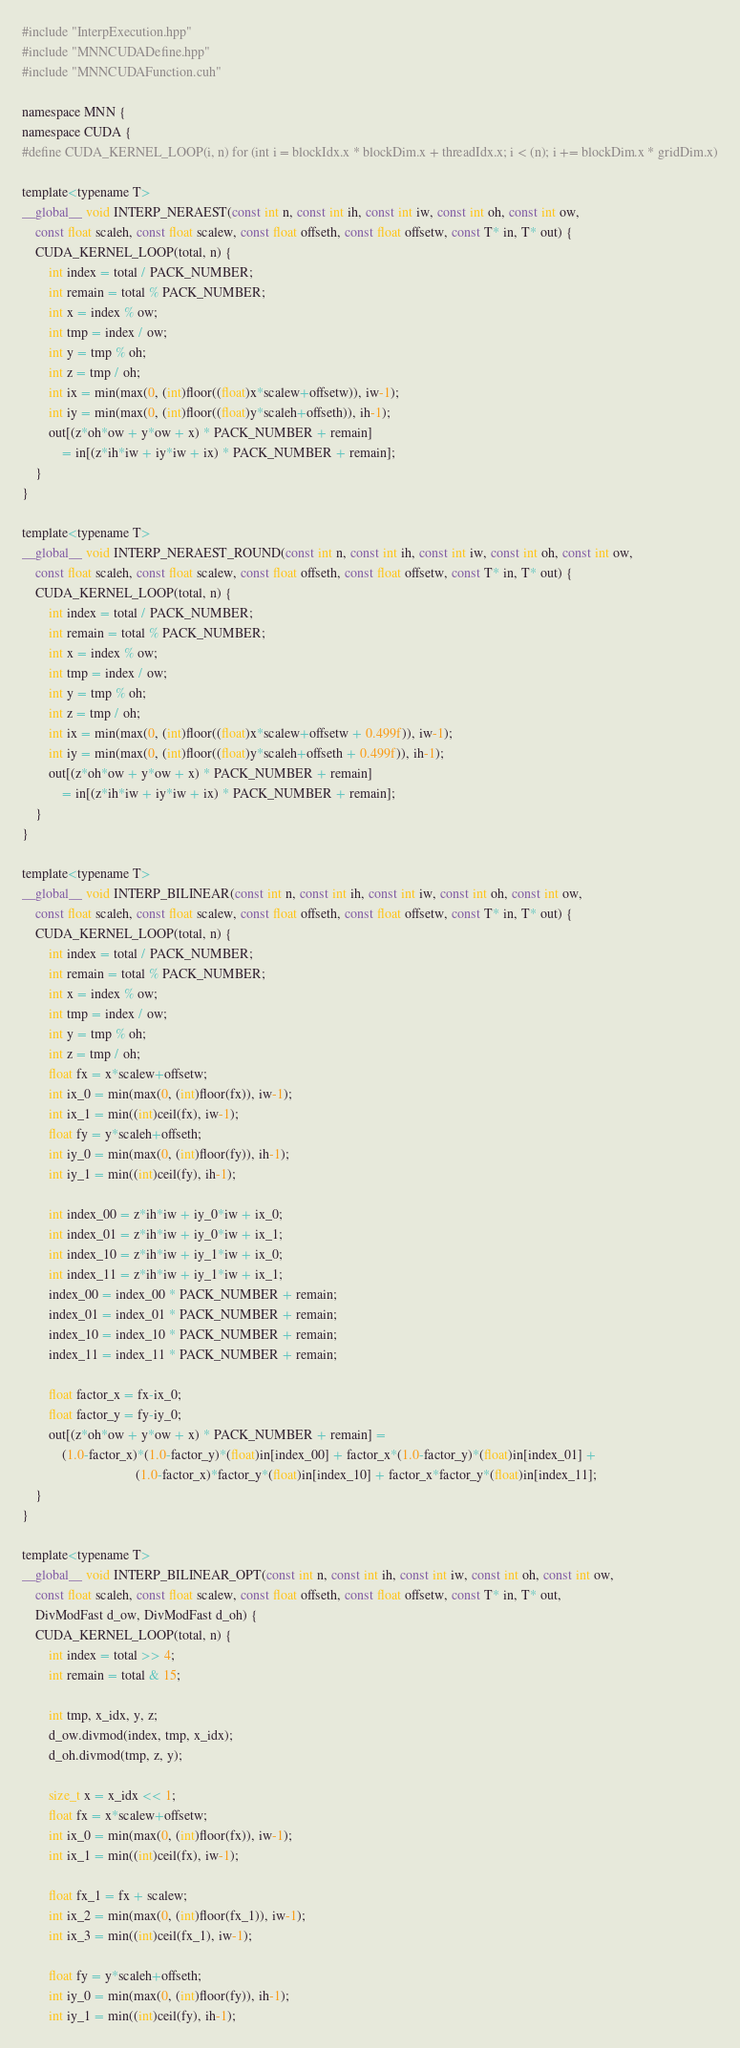<code> <loc_0><loc_0><loc_500><loc_500><_Cuda_>#include "InterpExecution.hpp"
#include "MNNCUDADefine.hpp"
#include "MNNCUDAFunction.cuh"

namespace MNN {
namespace CUDA {
#define CUDA_KERNEL_LOOP(i, n) for (int i = blockIdx.x * blockDim.x + threadIdx.x; i < (n); i += blockDim.x * gridDim.x)

template<typename T>
__global__ void INTERP_NERAEST(const int n, const int ih, const int iw, const int oh, const int ow, 
    const float scaleh, const float scalew, const float offseth, const float offsetw, const T* in, T* out) {
    CUDA_KERNEL_LOOP(total, n) {
        int index = total / PACK_NUMBER;
        int remain = total % PACK_NUMBER;
        int x = index % ow;
        int tmp = index / ow;
        int y = tmp % oh;
        int z = tmp / oh;
        int ix = min(max(0, (int)floor((float)x*scalew+offsetw)), iw-1);
        int iy = min(max(0, (int)floor((float)y*scaleh+offseth)), ih-1);
        out[(z*oh*ow + y*ow + x) * PACK_NUMBER + remain]
            = in[(z*ih*iw + iy*iw + ix) * PACK_NUMBER + remain];
    }
}

template<typename T>
__global__ void INTERP_NERAEST_ROUND(const int n, const int ih, const int iw, const int oh, const int ow, 
    const float scaleh, const float scalew, const float offseth, const float offsetw, const T* in, T* out) {
    CUDA_KERNEL_LOOP(total, n) {
        int index = total / PACK_NUMBER;
        int remain = total % PACK_NUMBER;
        int x = index % ow;
        int tmp = index / ow;
        int y = tmp % oh;
        int z = tmp / oh;
        int ix = min(max(0, (int)floor((float)x*scalew+offsetw + 0.499f)), iw-1);
        int iy = min(max(0, (int)floor((float)y*scaleh+offseth + 0.499f)), ih-1);
        out[(z*oh*ow + y*ow + x) * PACK_NUMBER + remain]
            = in[(z*ih*iw + iy*iw + ix) * PACK_NUMBER + remain];
    }
}

template<typename T>
__global__ void INTERP_BILINEAR(const int n, const int ih, const int iw, const int oh, const int ow, 
    const float scaleh, const float scalew, const float offseth, const float offsetw, const T* in, T* out) {
    CUDA_KERNEL_LOOP(total, n) {
        int index = total / PACK_NUMBER;
        int remain = total % PACK_NUMBER;
        int x = index % ow;
        int tmp = index / ow;
        int y = tmp % oh;
        int z = tmp / oh;
        float fx = x*scalew+offsetw;
        int ix_0 = min(max(0, (int)floor(fx)), iw-1);
        int ix_1 = min((int)ceil(fx), iw-1);
        float fy = y*scaleh+offseth;
        int iy_0 = min(max(0, (int)floor(fy)), ih-1);
        int iy_1 = min((int)ceil(fy), ih-1);

        int index_00 = z*ih*iw + iy_0*iw + ix_0;
        int index_01 = z*ih*iw + iy_0*iw + ix_1;
        int index_10 = z*ih*iw + iy_1*iw + ix_0;
        int index_11 = z*ih*iw + iy_1*iw + ix_1;
        index_00 = index_00 * PACK_NUMBER + remain;
        index_01 = index_01 * PACK_NUMBER + remain;
        index_10 = index_10 * PACK_NUMBER + remain;
        index_11 = index_11 * PACK_NUMBER + remain;

        float factor_x = fx-ix_0;
        float factor_y = fy-iy_0;
        out[(z*oh*ow + y*ow + x) * PACK_NUMBER + remain] =
            (1.0-factor_x)*(1.0-factor_y)*(float)in[index_00] + factor_x*(1.0-factor_y)*(float)in[index_01] +
                                  (1.0-factor_x)*factor_y*(float)in[index_10] + factor_x*factor_y*(float)in[index_11];
    }
}

template<typename T>
__global__ void INTERP_BILINEAR_OPT(const int n, const int ih, const int iw, const int oh, const int ow, 
    const float scaleh, const float scalew, const float offseth, const float offsetw, const T* in, T* out,
    DivModFast d_ow, DivModFast d_oh) {
    CUDA_KERNEL_LOOP(total, n) {
        int index = total >> 4;
        int remain = total & 15;

        int tmp, x_idx, y, z;
        d_ow.divmod(index, tmp, x_idx);
        d_oh.divmod(tmp, z, y);

        size_t x = x_idx << 1;
        float fx = x*scalew+offsetw;
        int ix_0 = min(max(0, (int)floor(fx)), iw-1);
        int ix_1 = min((int)ceil(fx), iw-1);

        float fx_1 = fx + scalew;
        int ix_2 = min(max(0, (int)floor(fx_1)), iw-1);
        int ix_3 = min((int)ceil(fx_1), iw-1);

        float fy = y*scaleh+offseth;
        int iy_0 = min(max(0, (int)floor(fy)), ih-1);
        int iy_1 = min((int)ceil(fy), ih-1);
</code> 